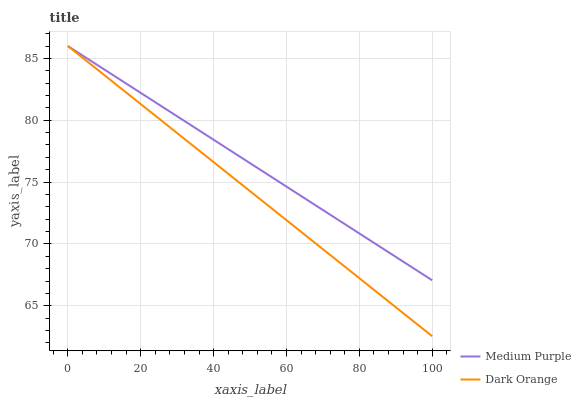Does Dark Orange have the minimum area under the curve?
Answer yes or no. Yes. Does Medium Purple have the maximum area under the curve?
Answer yes or no. Yes. Does Dark Orange have the maximum area under the curve?
Answer yes or no. No. Is Dark Orange the smoothest?
Answer yes or no. Yes. Is Medium Purple the roughest?
Answer yes or no. Yes. Is Dark Orange the roughest?
Answer yes or no. No. Does Dark Orange have the lowest value?
Answer yes or no. Yes. Does Dark Orange have the highest value?
Answer yes or no. Yes. Does Dark Orange intersect Medium Purple?
Answer yes or no. Yes. Is Dark Orange less than Medium Purple?
Answer yes or no. No. Is Dark Orange greater than Medium Purple?
Answer yes or no. No. 